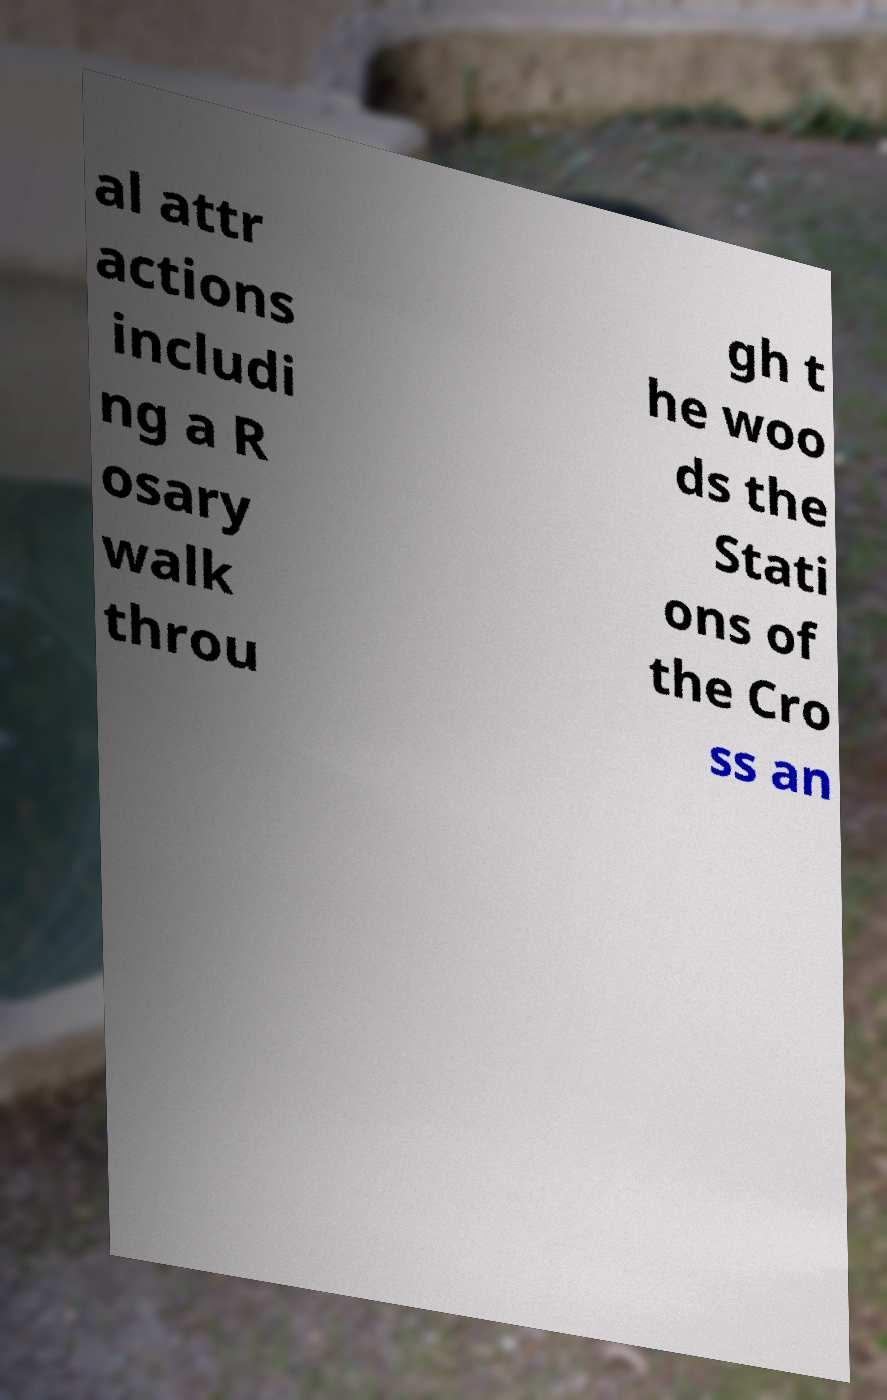Please identify and transcribe the text found in this image. al attr actions includi ng a R osary walk throu gh t he woo ds the Stati ons of the Cro ss an 